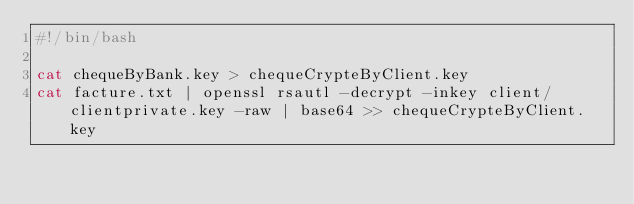<code> <loc_0><loc_0><loc_500><loc_500><_Bash_>#!/bin/bash

cat chequeByBank.key > chequeCrypteByClient.key
cat facture.txt | openssl rsautl -decrypt -inkey client/clientprivate.key -raw | base64 >> chequeCrypteByClient.key
</code> 